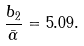<formula> <loc_0><loc_0><loc_500><loc_500>\frac { b _ { 2 } } { \bar { \alpha } } = 5 . 0 9 . \\</formula> 